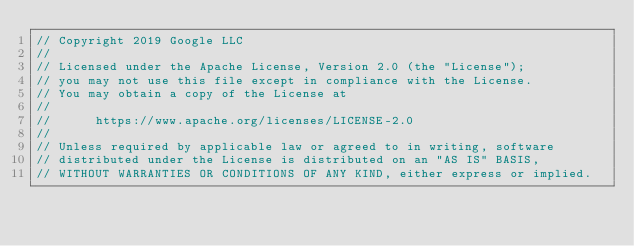Convert code to text. <code><loc_0><loc_0><loc_500><loc_500><_C_>// Copyright 2019 Google LLC
//
// Licensed under the Apache License, Version 2.0 (the "License");
// you may not use this file except in compliance with the License.
// You may obtain a copy of the License at
//
//      https://www.apache.org/licenses/LICENSE-2.0
//
// Unless required by applicable law or agreed to in writing, software
// distributed under the License is distributed on an "AS IS" BASIS,
// WITHOUT WARRANTIES OR CONDITIONS OF ANY KIND, either express or implied.</code> 